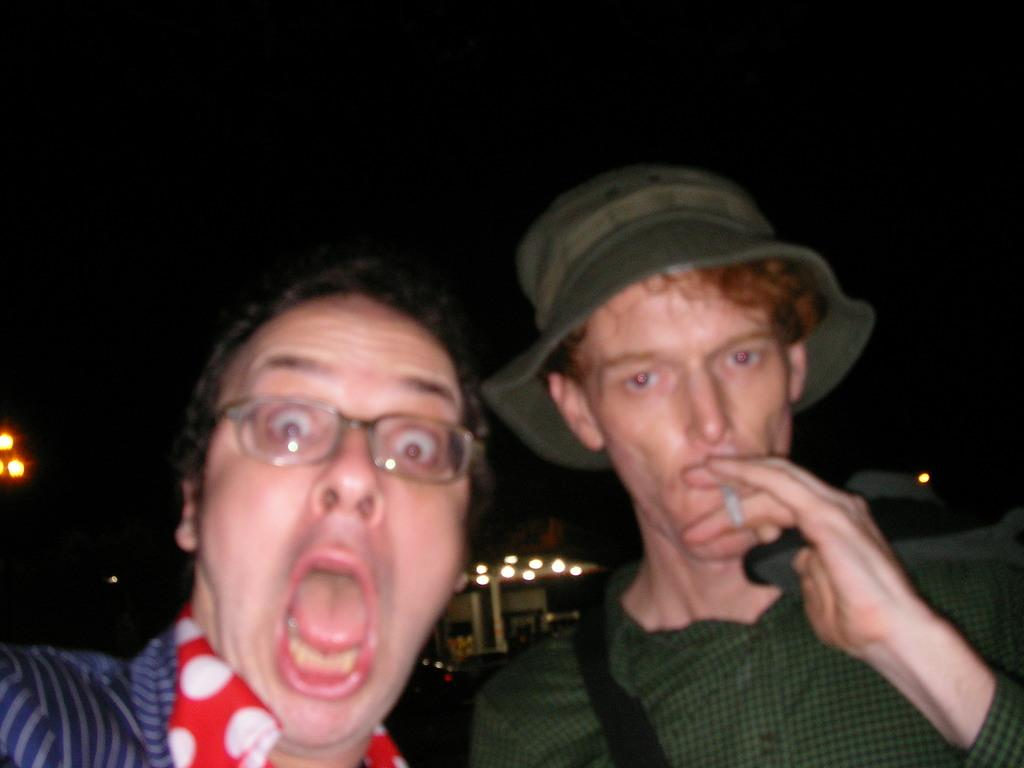How many people are in the image? There are two men in the image. What are the men wearing? Both men are wearing clothes. Can you describe the clothing of the man on the right side? The man on the right side is wearing a hat. Can you describe the clothing of the man on the left side? The man on the left side is wearing spectacles. What is the color of the background in the image? The background of the image is dark. Can you see any swings or the sea in the image? No, there are no swings or sea visible in the image. What type of observation can be made about the men's clothing in the image? There is no specific observation about the men's clothing in the image; we only know that one man is wearing a hat and the other is wearing spectacles. 